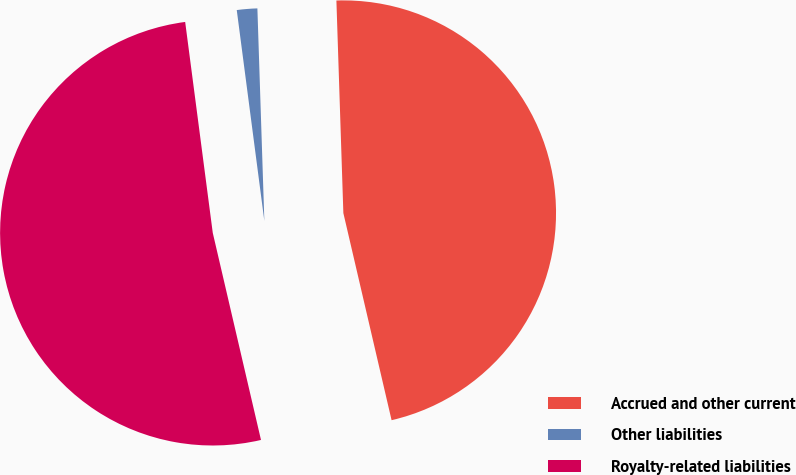Convert chart to OTSL. <chart><loc_0><loc_0><loc_500><loc_500><pie_chart><fcel>Accrued and other current<fcel>Other liabilities<fcel>Royalty-related liabilities<nl><fcel>46.88%<fcel>1.55%<fcel>51.57%<nl></chart> 